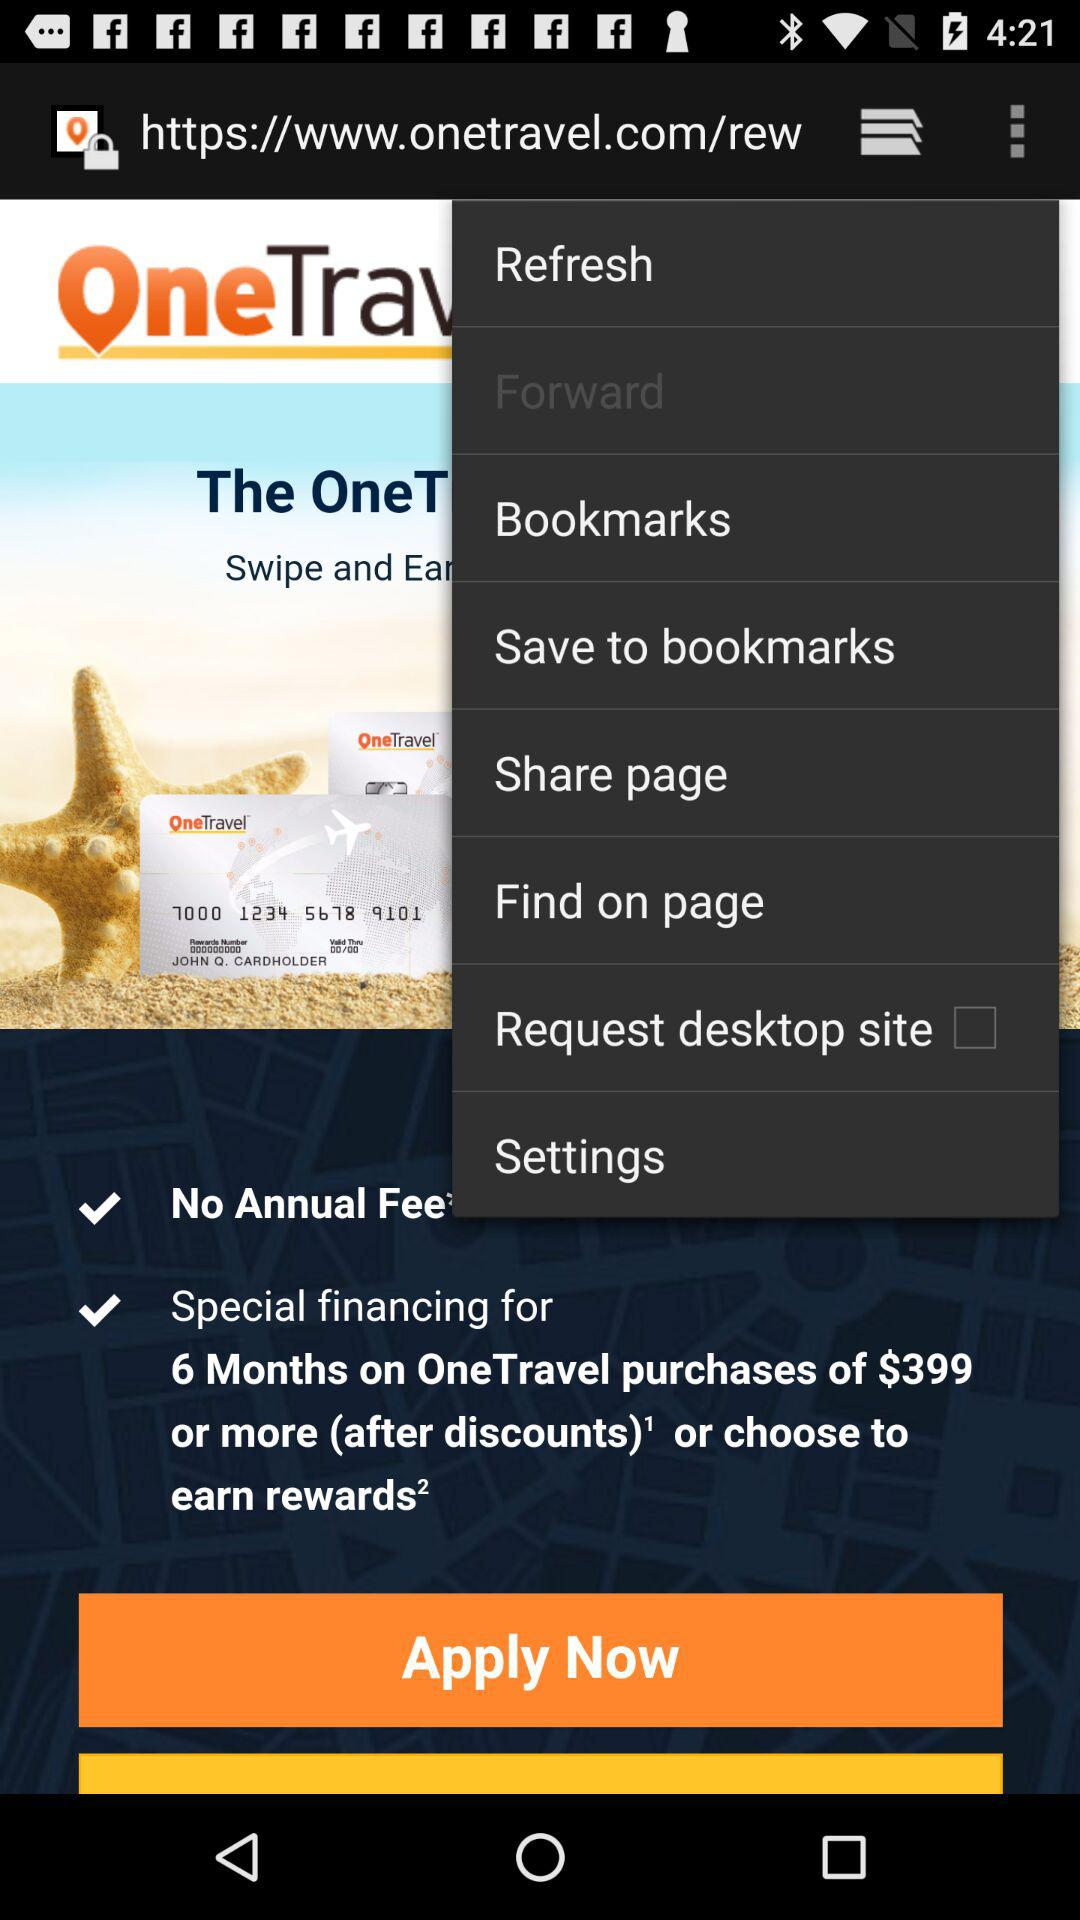Which option is selected? The selected option is "Forward". 